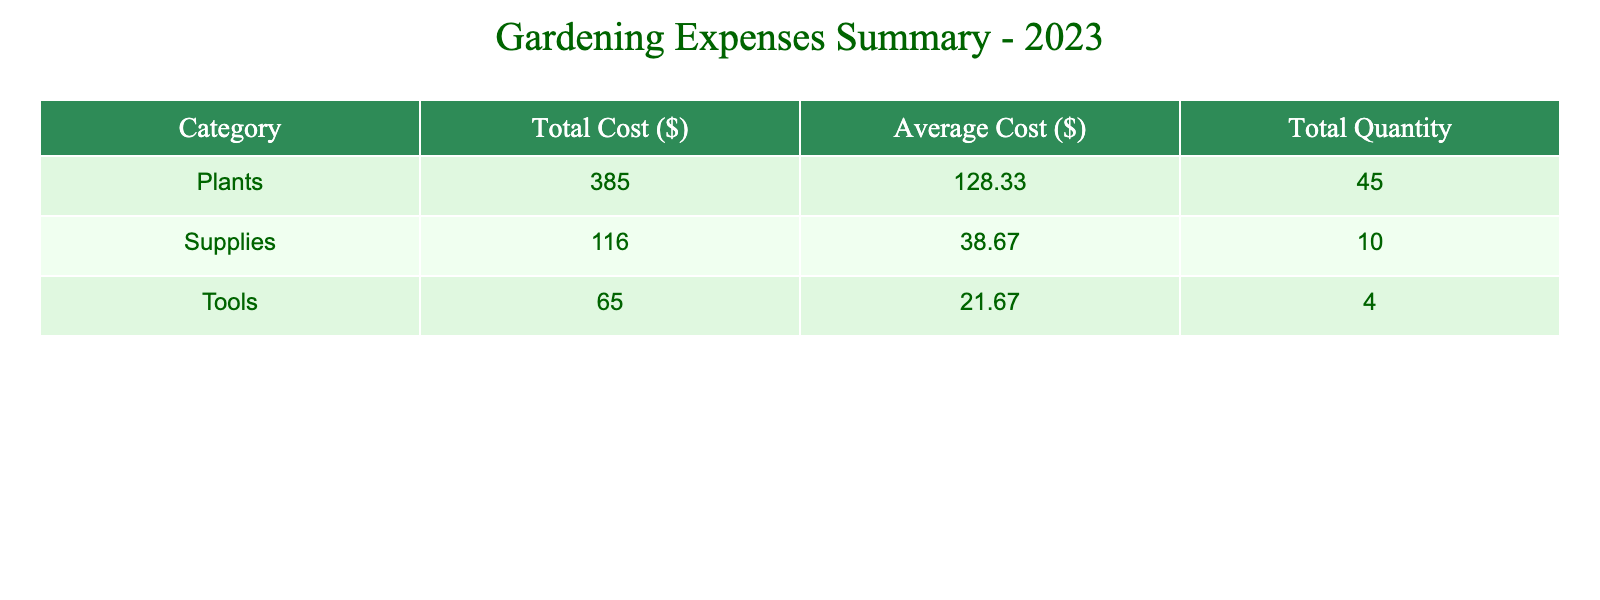What is the total cost for purchasing annual plants? To find the total cost for annual plants, we refer to the row labeled "Annuals" under the "Plants" category and see the total cost listed as 160.00.
Answer: 160.00 Which category had the highest total cost? By comparing the total costs for each category from the summary: Plants (150 + 160 + 75 = 385), Tools (25 + 20 + 20 = 65), and Supplies (50 + 30 + 36 = 116), it is clear that the Plants category has the highest total cost of 385.
Answer: Plants How many perennials were purchased? From the table, we see that under the "Perennials" entry in the "Plants" category, the quantity purchased is clearly stated as 10.
Answer: 10 What is the average cost per item for gardening tools? The average cost per item for tools is calculated by taking the total cost (25 + 20 + 20 = 65) and dividing it by the number of different tool types (which is 3: Garden Spade, Pruning Shears, Gardening Gloves). Thus, the average cost per item is 65 / 3 = 21.67.
Answer: 21.67 Is the total cost for supplies greater than the total cost for tools? The total cost for supplies (50 + 30 + 36 = 116) is compared with the total cost for tools (25 + 20 + 20 = 65). Since 116 is greater than 65, the statement is true.
Answer: Yes What is the total quantity of all items purchased? To calculate the total quantity, we sum up the "Quantity Purchased" for all items listed: 10 (Perennials) + 20 (Annuals) + 15 (Herbs) + 1 (Garden Spade) + 1 (Pruning Shears) + 2 (Gardening Gloves) + 5 (Potting Soil Bags) + 2 (Fertilizer Bags) + 3 (Weed Barrier Fabric) = 59 total items purchased.
Answer: 59 How much was spent on supplies compared to plants? The total spent on supplies is 116 (calculated from 50 for potting soil, 30 for fertilizer, and 36 for weed barrier fabric). The total spent on plants is 385. Therefore, the question can be addressed by comparing 116 to 385, indicating a clear difference.
Answer: Supplies is less than Plants What is the mean quantity of items purchased across all categories? First, we sum the total quantity purchased across all categories: 10 + 20 + 15 + 1 + 1 + 2 + 5 + 2 + 3 = 59. To find the mean, we divide 59 by the number of unique categories (3: Plants, Tools, Supplies), thus 59 / 3 = 19.67.
Answer: 19.67 